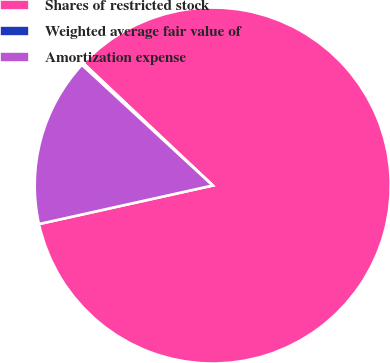<chart> <loc_0><loc_0><loc_500><loc_500><pie_chart><fcel>Shares of restricted stock<fcel>Weighted average fair value of<fcel>Amortization expense<nl><fcel>84.48%<fcel>0.19%<fcel>15.33%<nl></chart> 